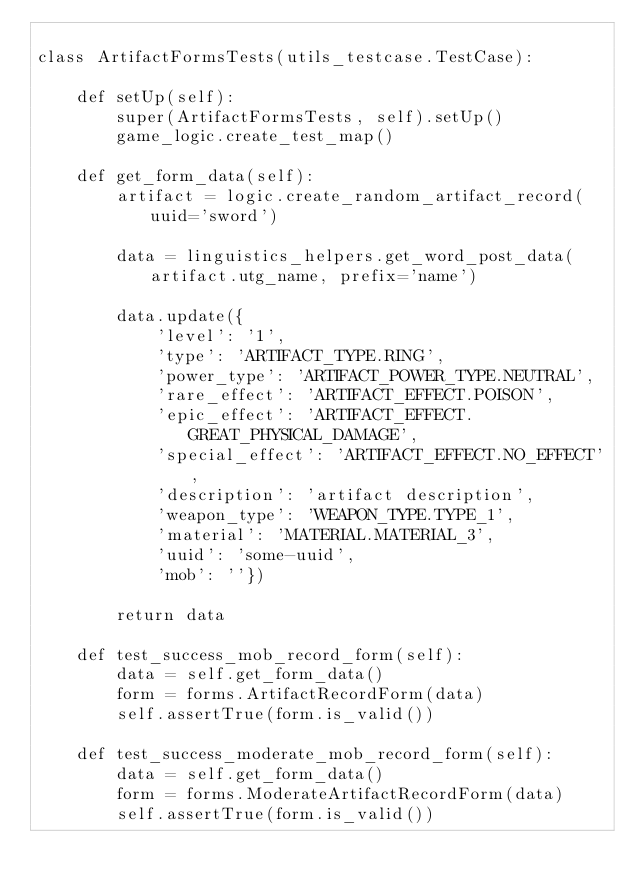Convert code to text. <code><loc_0><loc_0><loc_500><loc_500><_Python_>
class ArtifactFormsTests(utils_testcase.TestCase):

    def setUp(self):
        super(ArtifactFormsTests, self).setUp()
        game_logic.create_test_map()

    def get_form_data(self):
        artifact = logic.create_random_artifact_record(uuid='sword')

        data = linguistics_helpers.get_word_post_data(artifact.utg_name, prefix='name')

        data.update({
            'level': '1',
            'type': 'ARTIFACT_TYPE.RING',
            'power_type': 'ARTIFACT_POWER_TYPE.NEUTRAL',
            'rare_effect': 'ARTIFACT_EFFECT.POISON',
            'epic_effect': 'ARTIFACT_EFFECT.GREAT_PHYSICAL_DAMAGE',
            'special_effect': 'ARTIFACT_EFFECT.NO_EFFECT',
            'description': 'artifact description',
            'weapon_type': 'WEAPON_TYPE.TYPE_1',
            'material': 'MATERIAL.MATERIAL_3',
            'uuid': 'some-uuid',
            'mob': ''})

        return data

    def test_success_mob_record_form(self):
        data = self.get_form_data()
        form = forms.ArtifactRecordForm(data)
        self.assertTrue(form.is_valid())

    def test_success_moderate_mob_record_form(self):
        data = self.get_form_data()
        form = forms.ModerateArtifactRecordForm(data)
        self.assertTrue(form.is_valid())
</code> 